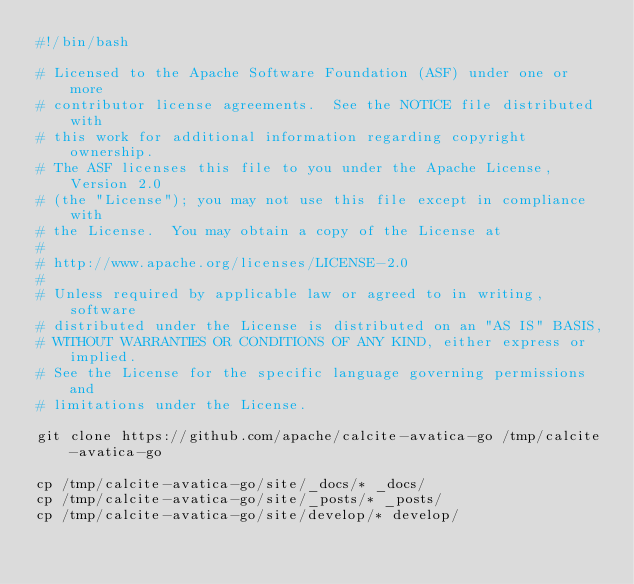Convert code to text. <code><loc_0><loc_0><loc_500><loc_500><_Bash_>#!/bin/bash

# Licensed to the Apache Software Foundation (ASF) under one or more
# contributor license agreements.  See the NOTICE file distributed with
# this work for additional information regarding copyright ownership.
# The ASF licenses this file to you under the Apache License, Version 2.0
# (the "License"); you may not use this file except in compliance with
# the License.  You may obtain a copy of the License at
#
# http://www.apache.org/licenses/LICENSE-2.0
#
# Unless required by applicable law or agreed to in writing, software
# distributed under the License is distributed on an "AS IS" BASIS,
# WITHOUT WARRANTIES OR CONDITIONS OF ANY KIND, either express or implied.
# See the License for the specific language governing permissions and
# limitations under the License.

git clone https://github.com/apache/calcite-avatica-go /tmp/calcite-avatica-go

cp /tmp/calcite-avatica-go/site/_docs/* _docs/
cp /tmp/calcite-avatica-go/site/_posts/* _posts/
cp /tmp/calcite-avatica-go/site/develop/* develop/
</code> 